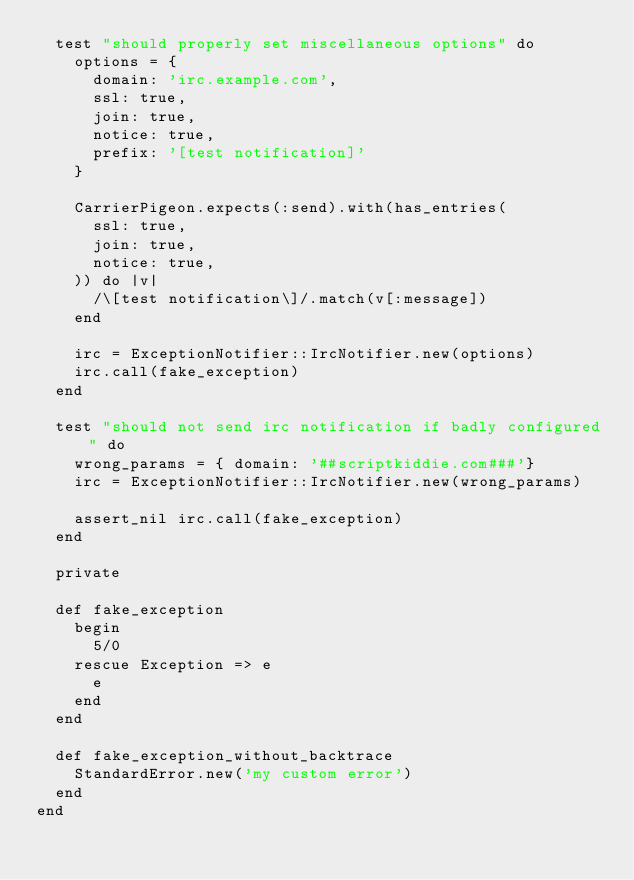<code> <loc_0><loc_0><loc_500><loc_500><_Ruby_>  test "should properly set miscellaneous options" do
    options = {
      domain: 'irc.example.com',
      ssl: true,
      join: true,
      notice: true,
      prefix: '[test notification]'
    }

    CarrierPigeon.expects(:send).with(has_entries(
      ssl: true,
      join: true,
      notice: true,
    )) do |v|
      /\[test notification\]/.match(v[:message])
    end

    irc = ExceptionNotifier::IrcNotifier.new(options)
    irc.call(fake_exception)
  end

  test "should not send irc notification if badly configured" do
    wrong_params = { domain: '##scriptkiddie.com###'}
    irc = ExceptionNotifier::IrcNotifier.new(wrong_params)

    assert_nil irc.call(fake_exception)
  end

  private

  def fake_exception
    begin
      5/0
    rescue Exception => e
      e
    end
  end

  def fake_exception_without_backtrace
    StandardError.new('my custom error')
  end
end
</code> 